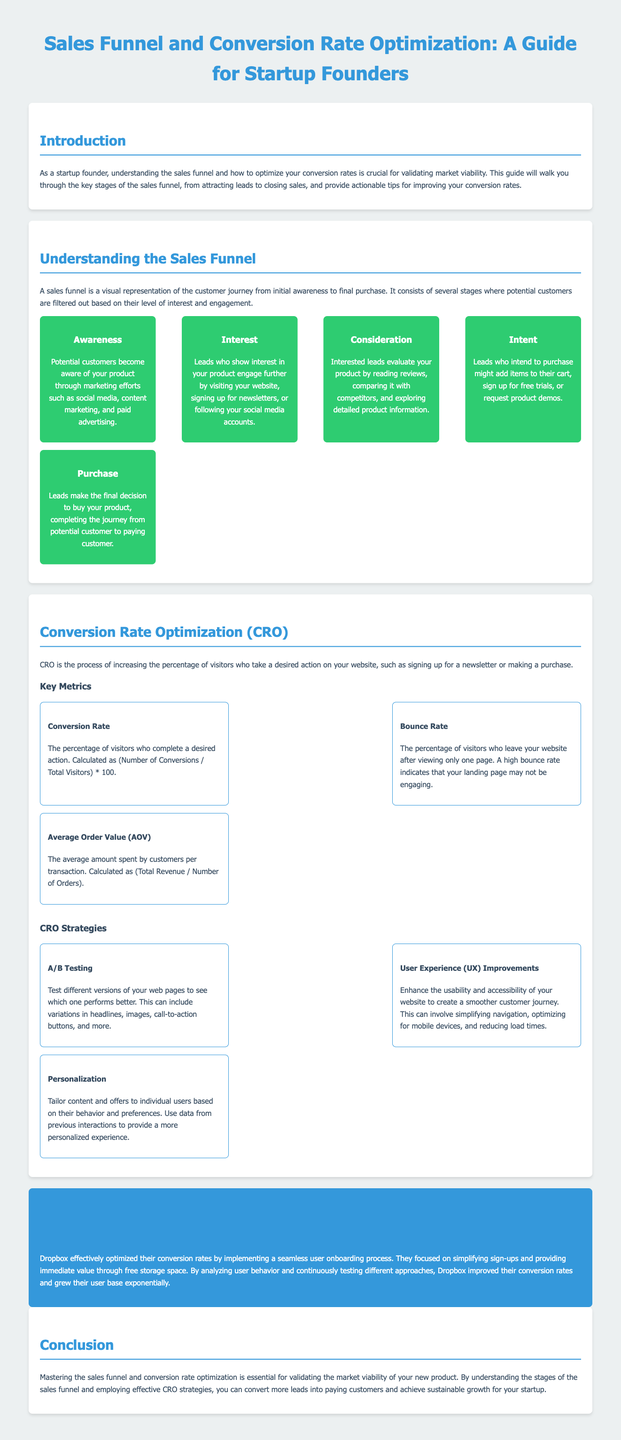What are the stages of the sales funnel? The stages of the sales funnel are listed in the document as Awareness, Interest, Consideration, Intent, and Purchase.
Answer: Awareness, Interest, Consideration, Intent, Purchase What is the formula for Conversion Rate? The formula for Conversion Rate is outlined in the document as (Number of Conversions / Total Visitors) * 100.
Answer: (Number of Conversions / Total Visitors) * 100 What is the purpose of Conversion Rate Optimization (CRO)? The document explains that the purpose of CRO is to increase the percentage of visitors who take a desired action on your website.
Answer: Increase the percentage of visitors who take a desired action Which company is mentioned in the case study? The case study in the document focuses on Dropbox as an example of effective conversion rate optimization.
Answer: Dropbox What is the Average Order Value (AOV)? The AOV is defined in the document as the average amount spent by customers per transaction, calculated as (Total Revenue / Number of Orders).
Answer: Average amount spent per transaction What is one of the strategies for CRO mentioned? The document lists A/B Testing, User Experience Improvements, and Personalization as strategies for CRO.
Answer: A/B Testing What indicator suggests that a landing page may not be engaging? The document states that a high bounce rate indicates potential issues with the landing page’s engagement.
Answer: High bounce rate 